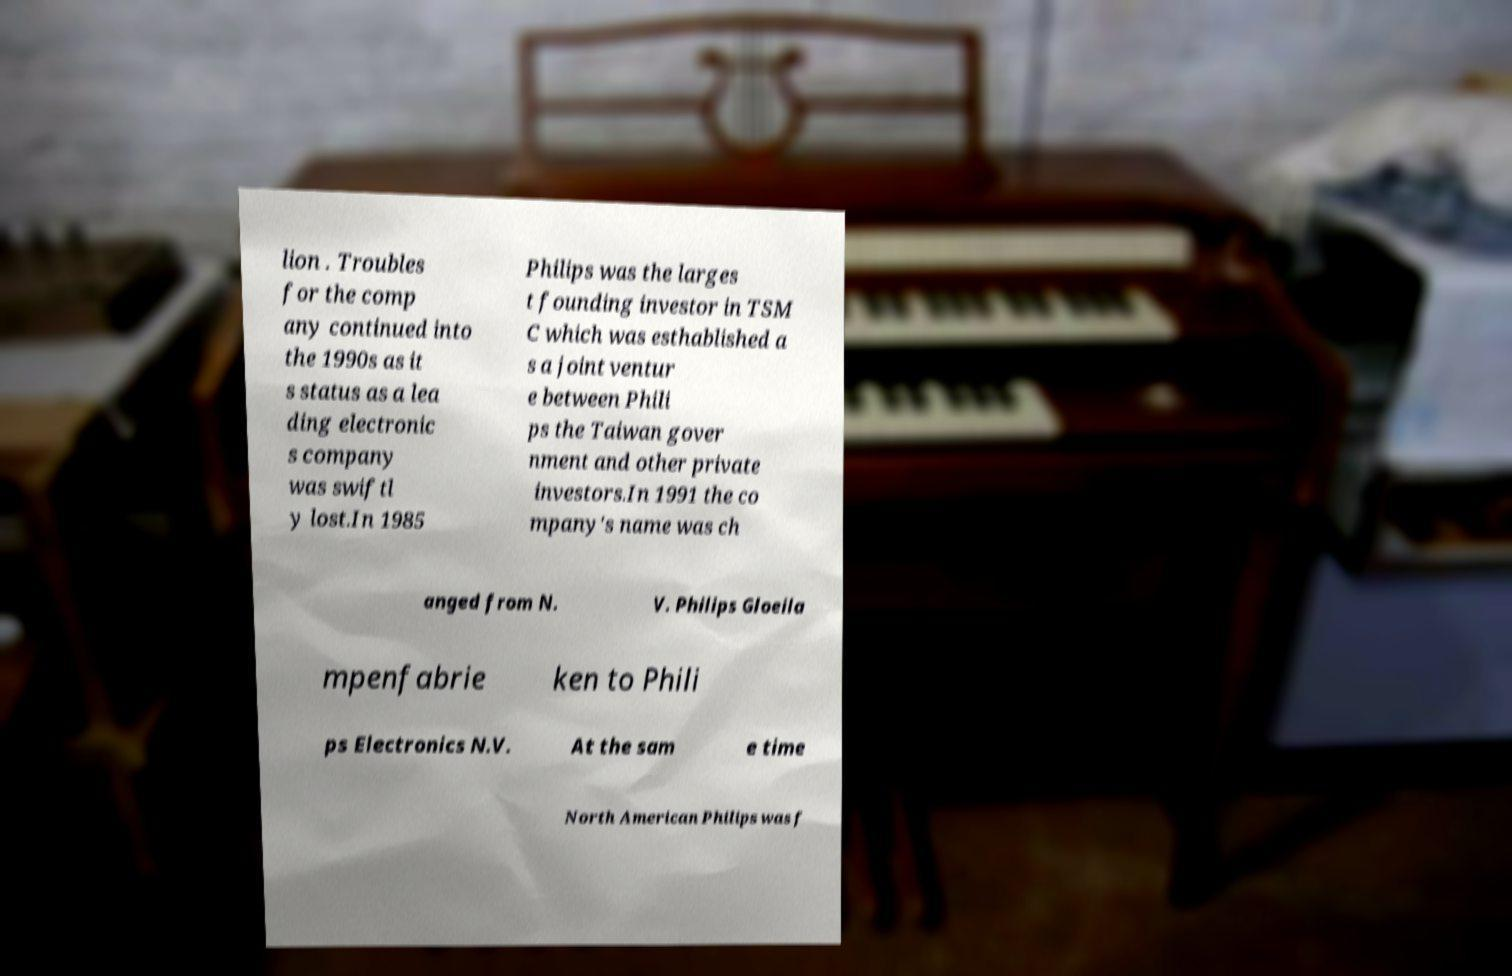Could you extract and type out the text from this image? lion . Troubles for the comp any continued into the 1990s as it s status as a lea ding electronic s company was swiftl y lost.In 1985 Philips was the larges t founding investor in TSM C which was esthablished a s a joint ventur e between Phili ps the Taiwan gover nment and other private investors.In 1991 the co mpany's name was ch anged from N. V. Philips Gloeila mpenfabrie ken to Phili ps Electronics N.V. At the sam e time North American Philips was f 